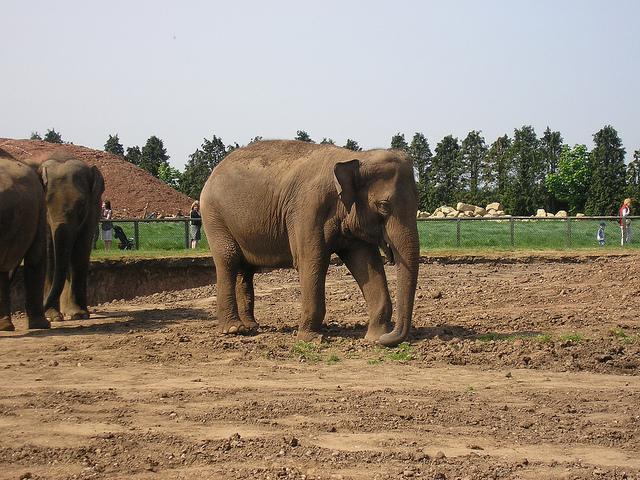How many elephants are visible?
Give a very brief answer. 3. 